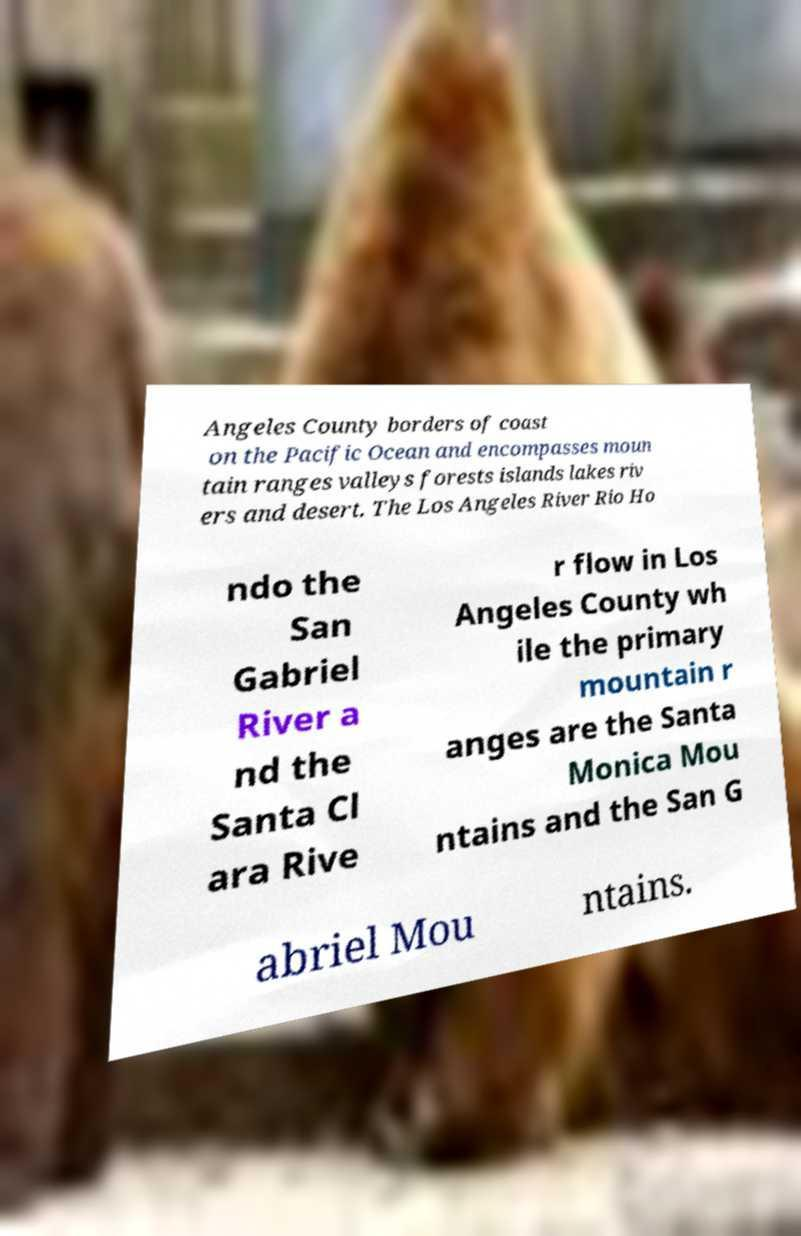What messages or text are displayed in this image? I need them in a readable, typed format. Angeles County borders of coast on the Pacific Ocean and encompasses moun tain ranges valleys forests islands lakes riv ers and desert. The Los Angeles River Rio Ho ndo the San Gabriel River a nd the Santa Cl ara Rive r flow in Los Angeles County wh ile the primary mountain r anges are the Santa Monica Mou ntains and the San G abriel Mou ntains. 